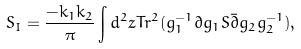Convert formula to latex. <formula><loc_0><loc_0><loc_500><loc_500>S _ { I } = { \frac { - k _ { 1 } k _ { 2 } } { \pi } } \int d ^ { 2 } z T r ^ { 2 } ( g _ { 1 } ^ { - 1 } \partial g _ { 1 } S \bar { \partial } g _ { 2 } g _ { 2 } ^ { - 1 } ) ,</formula> 